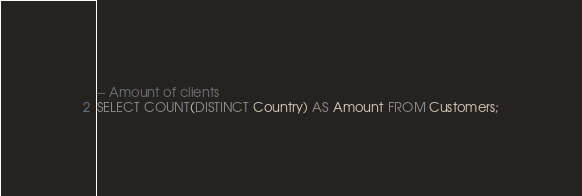Convert code to text. <code><loc_0><loc_0><loc_500><loc_500><_SQL_>-- Amount of clients
SELECT COUNT(DISTINCT Country) AS Amount FROM Customers;
</code> 